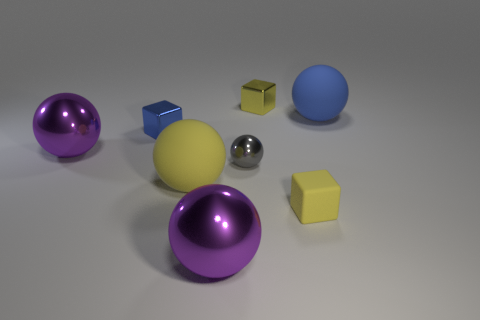There is another tiny cube that is the same color as the tiny rubber cube; what is its material?
Ensure brevity in your answer.  Metal. There is a small yellow matte thing; what number of big blue matte balls are on the left side of it?
Make the answer very short. 0. Is there a purple ball of the same size as the blue matte sphere?
Your answer should be compact. Yes. Are there any big matte objects that have the same color as the small rubber object?
Provide a short and direct response. Yes. What number of matte balls are the same color as the tiny metallic ball?
Ensure brevity in your answer.  0. Do the matte block and the small shiny cube right of the big yellow matte object have the same color?
Offer a terse response. Yes. How many objects are either gray shiny balls or shiny spheres behind the large yellow rubber ball?
Offer a very short reply. 2. What is the size of the matte ball that is on the left side of the yellow thing behind the gray sphere?
Offer a very short reply. Large. Are there an equal number of large purple things that are in front of the gray thing and blue things to the left of the tiny yellow shiny cube?
Keep it short and to the point. Yes. There is a small yellow matte object in front of the tiny blue shiny block; are there any large matte things right of it?
Offer a terse response. Yes. 